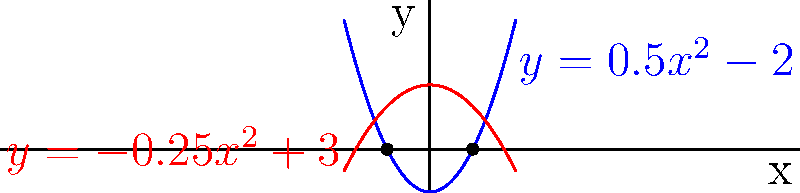In a payment gateway system, transaction volume (y) is modeled by two polynomial functions over time (x):

$$f(x) = 0.5x^2 - 2$$ (blue curve)
$$g(x) = -0.25x^2 + 3$$ (red curve)

Calculate the area between these two curves where they intersect. Round your answer to two decimal places. To solve this problem, we'll follow these steps:

1) Find the points of intersection:
   Set $f(x) = g(x)$:
   $0.5x^2 - 2 = -0.25x^2 + 3$
   $0.75x^2 = 5$
   $x^2 = \frac{20}{3}$
   $x = \pm \sqrt{\frac{20}{3}} \approx \pm 2.58$

   The intersection points are at $x \approx -2.58$ and $x \approx 2.58$

2) Calculate the area:
   Area = $\int_{-2.58}^{2.58} [g(x) - f(x)] dx$
   
   $= \int_{-2.58}^{2.58} [(-0.25x^2 + 3) - (0.5x^2 - 2)] dx$
   
   $= \int_{-2.58}^{2.58} [-0.75x^2 + 5] dx$
   
   $= [-0.25x^3 + 5x]_{-2.58}^{2.58}$

3) Evaluate the integral:
   $= [-0.25(2.58)^3 + 5(2.58)] - [-0.25(-2.58)^3 + 5(-2.58)]$
   
   $= [-4.29 + 12.9] - [4.29 - 12.9]$
   
   $= 8.61 + 8.61 = 17.22$

Therefore, the area between the curves is approximately 17.22 square units.
Answer: 17.22 square units 